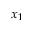<formula> <loc_0><loc_0><loc_500><loc_500>x _ { 1 }</formula> 